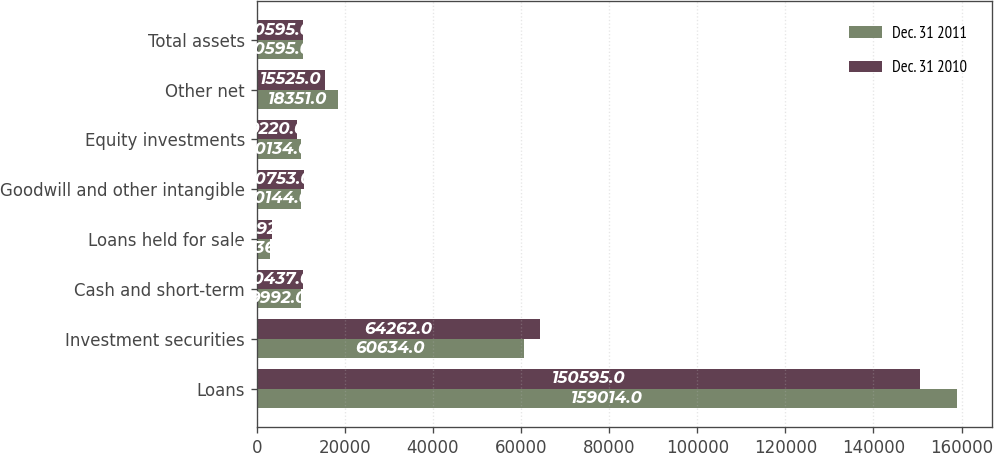<chart> <loc_0><loc_0><loc_500><loc_500><stacked_bar_chart><ecel><fcel>Loans<fcel>Investment securities<fcel>Cash and short-term<fcel>Loans held for sale<fcel>Goodwill and other intangible<fcel>Equity investments<fcel>Other net<fcel>Total assets<nl><fcel>Dec. 31 2011<fcel>159014<fcel>60634<fcel>9992<fcel>2936<fcel>10144<fcel>10134<fcel>18351<fcel>10595<nl><fcel>Dec. 31 2010<fcel>150595<fcel>64262<fcel>10437<fcel>3492<fcel>10753<fcel>9220<fcel>15525<fcel>10595<nl></chart> 